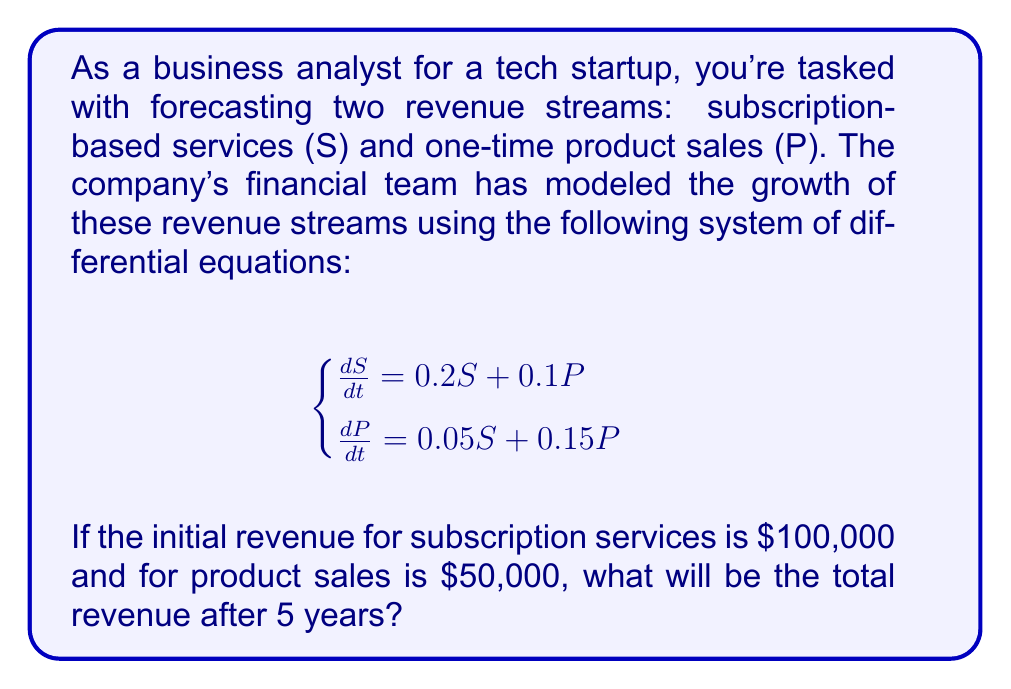Give your solution to this math problem. To solve this problem, we need to use the theory of systems of linear differential equations. Let's approach this step-by-step:

1) First, we need to write the system in matrix form:

   $$\frac{d}{dt}\begin{bmatrix} S \\ P \end{bmatrix} = \begin{bmatrix} 0.2 & 0.1 \\ 0.05 & 0.15 \end{bmatrix}\begin{bmatrix} S \\ P \end{bmatrix}$$

2) The general solution for this system is of the form:

   $$\begin{bmatrix} S \\ P \end{bmatrix} = c_1e^{\lambda_1t}\mathbf{v_1} + c_2e^{\lambda_2t}\mathbf{v_2}$$

   where $\lambda_1$ and $\lambda_2$ are the eigenvalues of the coefficient matrix, and $\mathbf{v_1}$ and $\mathbf{v_2}$ are the corresponding eigenvectors.

3) To find the eigenvalues, we solve the characteristic equation:

   $$\det(\begin{bmatrix} 0.2-\lambda & 0.1 \\ 0.05 & 0.15-\lambda \end{bmatrix}) = 0$$

   $$(0.2-\lambda)(0.15-\lambda) - 0.005 = 0$$
   $$\lambda^2 - 0.35\lambda + 0.025 = 0$$

4) Solving this quadratic equation gives us:

   $$\lambda_1 \approx 0.3207 \text{ and } \lambda_2 \approx 0.0293$$

5) For each eigenvalue, we can find the corresponding eigenvector. After normalization, we get:

   $$\mathbf{v_1} \approx \begin{bmatrix} 0.8944 \\ 0.4472 \end{bmatrix} \text{ and } \mathbf{v_2} \approx \begin{bmatrix} -0.4472 \\ 0.8944 \end{bmatrix}$$

6) Now, we can write the general solution:

   $$\begin{bmatrix} S \\ P \end{bmatrix} = c_1e^{0.3207t}\begin{bmatrix} 0.8944 \\ 0.4472 \end{bmatrix} + c_2e^{0.0293t}\begin{bmatrix} -0.4472 \\ 0.8944 \end{bmatrix}$$

7) To find $c_1$ and $c_2$, we use the initial conditions:

   $$\begin{bmatrix} 100000 \\ 50000 \end{bmatrix} = c_1\begin{bmatrix} 0.8944 \\ 0.4472 \end{bmatrix} + c_2\begin{bmatrix} -0.4472 \\ 0.8944 \end{bmatrix}$$

   Solving this system gives us: $c_1 \approx 111,803$ and $c_2 \approx 55,902$

8) Therefore, the solution for S and P is:

   $$S(t) \approx 100,000e^{0.3207t} - 25,000e^{0.0293t}$$
   $$P(t) \approx 50,000e^{0.3207t} + 50,000e^{0.0293t}$$

9) To find the total revenue after 5 years, we calculate S(5) + P(5):

   $$S(5) \approx 100,000e^{0.3207(5)} - 25,000e^{0.0293(5)} \approx 468,028$$
   $$P(5) \approx 50,000e^{0.3207(5)} + 50,000e^{0.0293(5)} \approx 291,514$$

   Total revenue = S(5) + P(5) ≈ 468,028 + 291,514 = 759,542
Answer: The total revenue after 5 years will be approximately $759,542. 